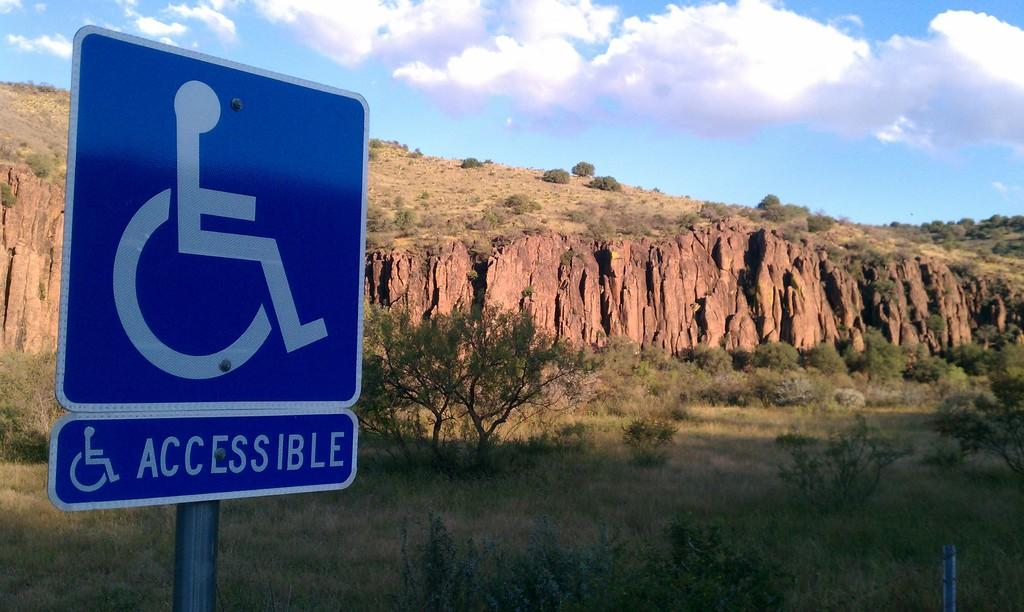<image>
Write a terse but informative summary of the picture. A blue handicap Accessible sign is show in front of a hill and cliff. 